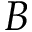Convert formula to latex. <formula><loc_0><loc_0><loc_500><loc_500>B</formula> 